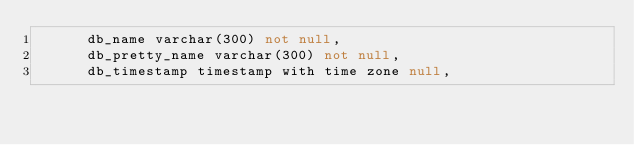<code> <loc_0><loc_0><loc_500><loc_500><_SQL_>      db_name varchar(300) not null,
      db_pretty_name varchar(300) not null,
      db_timestamp timestamp with time zone null,</code> 